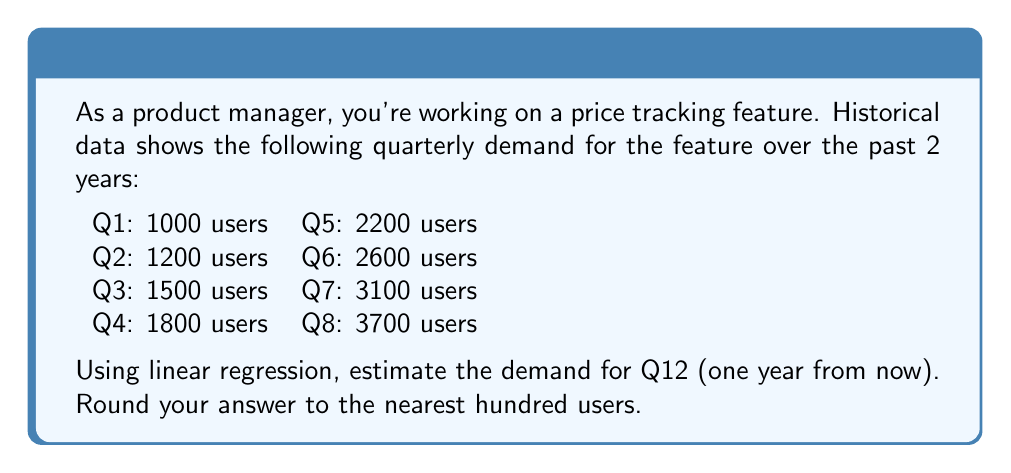Can you answer this question? To estimate future demand using linear regression, we'll follow these steps:

1) Let $x$ represent the quarter number and $y$ represent the demand.

2) Calculate the means of $x$ and $y$:
   $\bar{x} = \frac{1 + 2 + 3 + 4 + 5 + 6 + 7 + 8}{8} = 4.5$
   $\bar{y} = \frac{1000 + 1200 + 1500 + 1800 + 2200 + 2600 + 3100 + 3700}{8} = 2137.5$

3) Calculate the slope $m$ using the formula:
   $$m = \frac{\sum(x_i - \bar{x})(y_i - \bar{y})}{\sum(x_i - \bar{x})^2}$$

4) Simplify calculations:
   $\sum(x_i - \bar{x})(y_i - \bar{y}) = 11,550$
   $\sum(x_i - \bar{x})^2 = 42$

5) Calculate $m$:
   $m = \frac{11,550}{42} = 275$

6) Find the y-intercept $b$ using $y = mx + b$:
   $2137.5 = 275(4.5) + b$
   $b = 2137.5 - 1237.5 = 900$

7) The regression equation is:
   $y = 275x + 900$

8) To estimate demand for Q12, substitute $x = 12$:
   $y = 275(12) + 900 = 4200$

Therefore, the estimated demand for Q12 is 4200 users.
Answer: 4200 users 